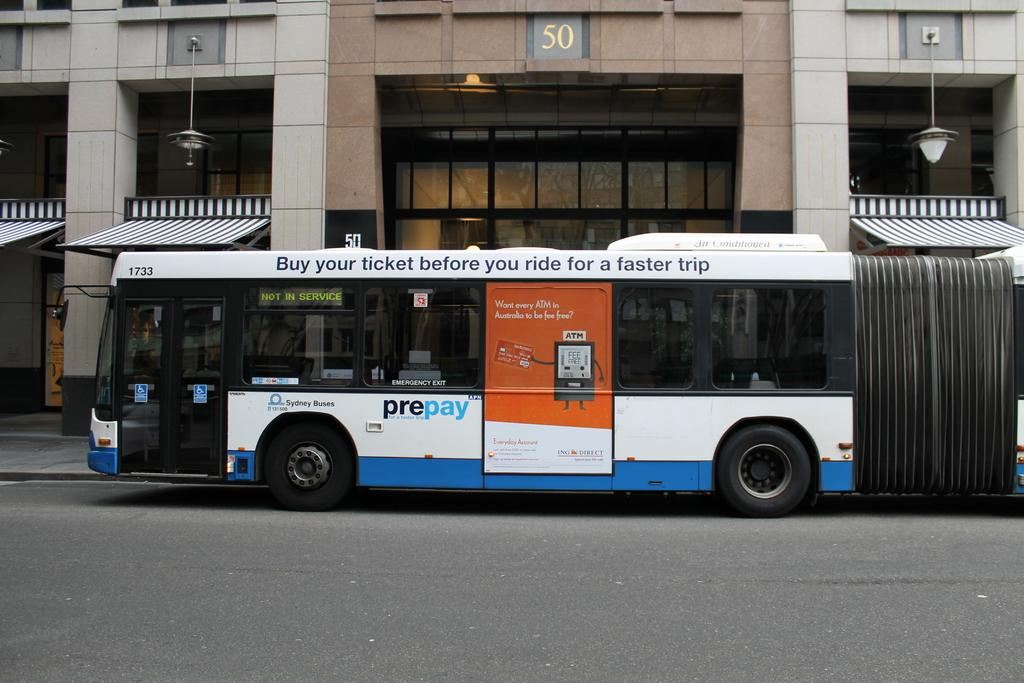<image>
Offer a succinct explanation of the picture presented. a bus that says 'buy your ticket before you ride for a faster trip' on it 